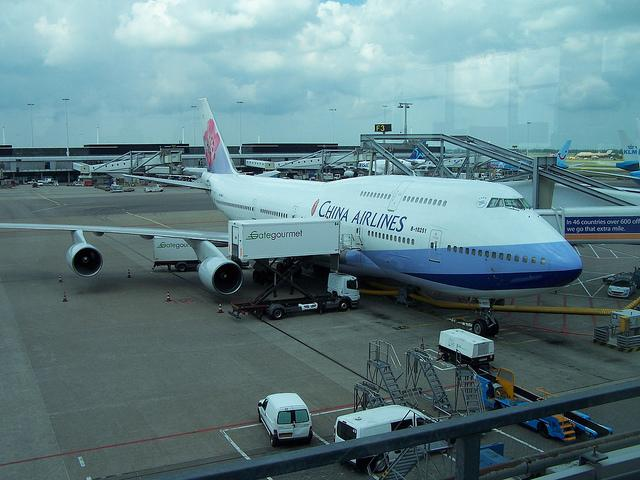How were the drivers of the cars able to park here? airport workers 